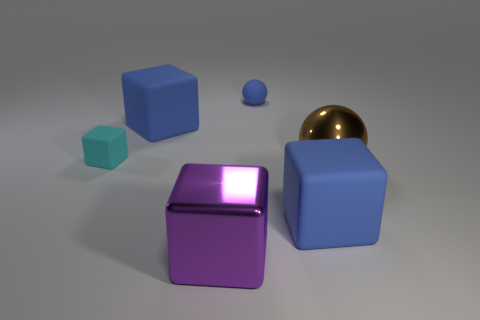How many blue objects are small matte things or matte blocks?
Make the answer very short. 3. Are there any other things that have the same material as the small cyan object?
Your answer should be very brief. Yes. Does the blue rubber object in front of the small cyan cube have the same shape as the large metal thing in front of the brown shiny ball?
Your answer should be very brief. Yes. What number of big objects are there?
Your response must be concise. 4. What is the shape of the tiny object that is made of the same material as the small cyan cube?
Your response must be concise. Sphere. Is there anything else that has the same color as the tiny matte sphere?
Offer a terse response. Yes. There is a small sphere; is it the same color as the rubber cube behind the cyan thing?
Offer a terse response. Yes. Are there fewer small blue things in front of the tiny cyan rubber object than big metal spheres?
Keep it short and to the point. Yes. What is the material of the blue object right of the matte ball?
Your answer should be compact. Rubber. What number of other objects are there of the same size as the cyan matte object?
Your response must be concise. 1. 